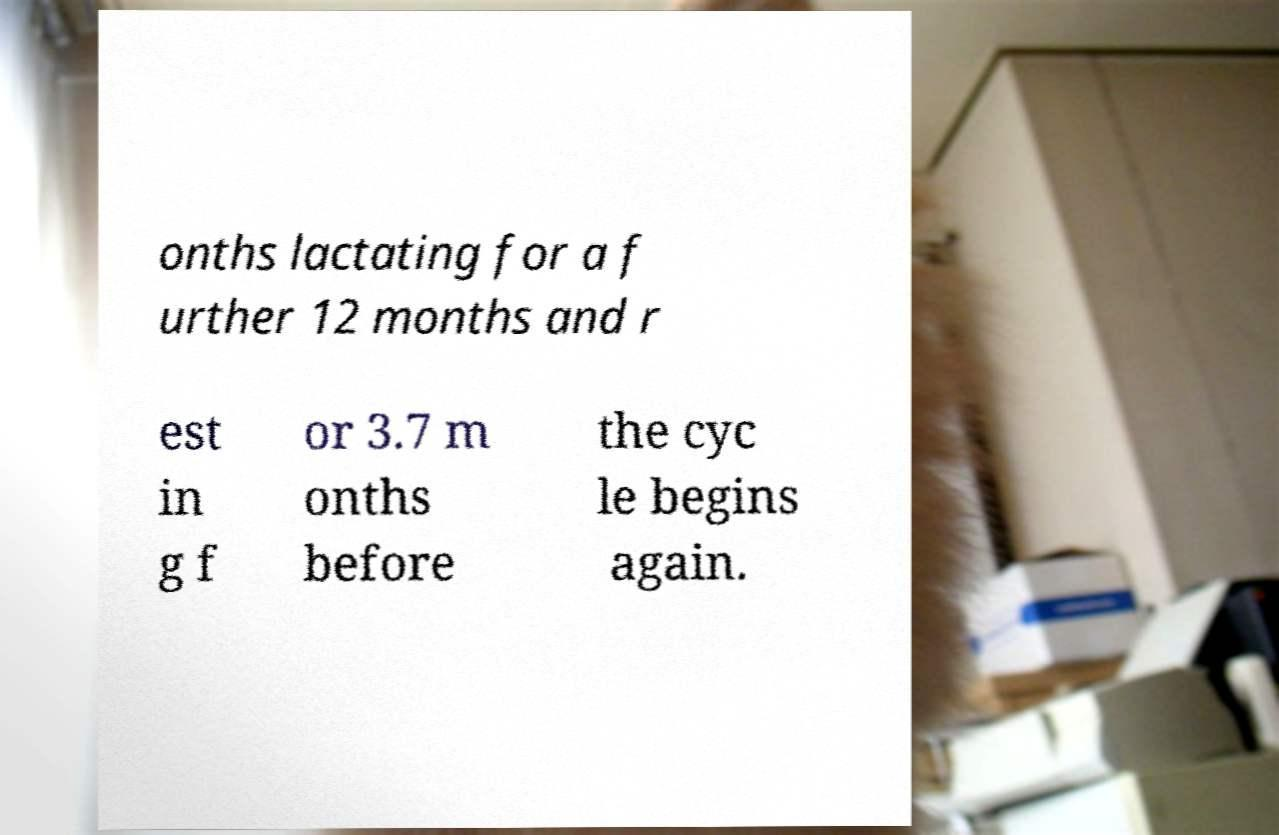There's text embedded in this image that I need extracted. Can you transcribe it verbatim? onths lactating for a f urther 12 months and r est in g f or 3.7 m onths before the cyc le begins again. 